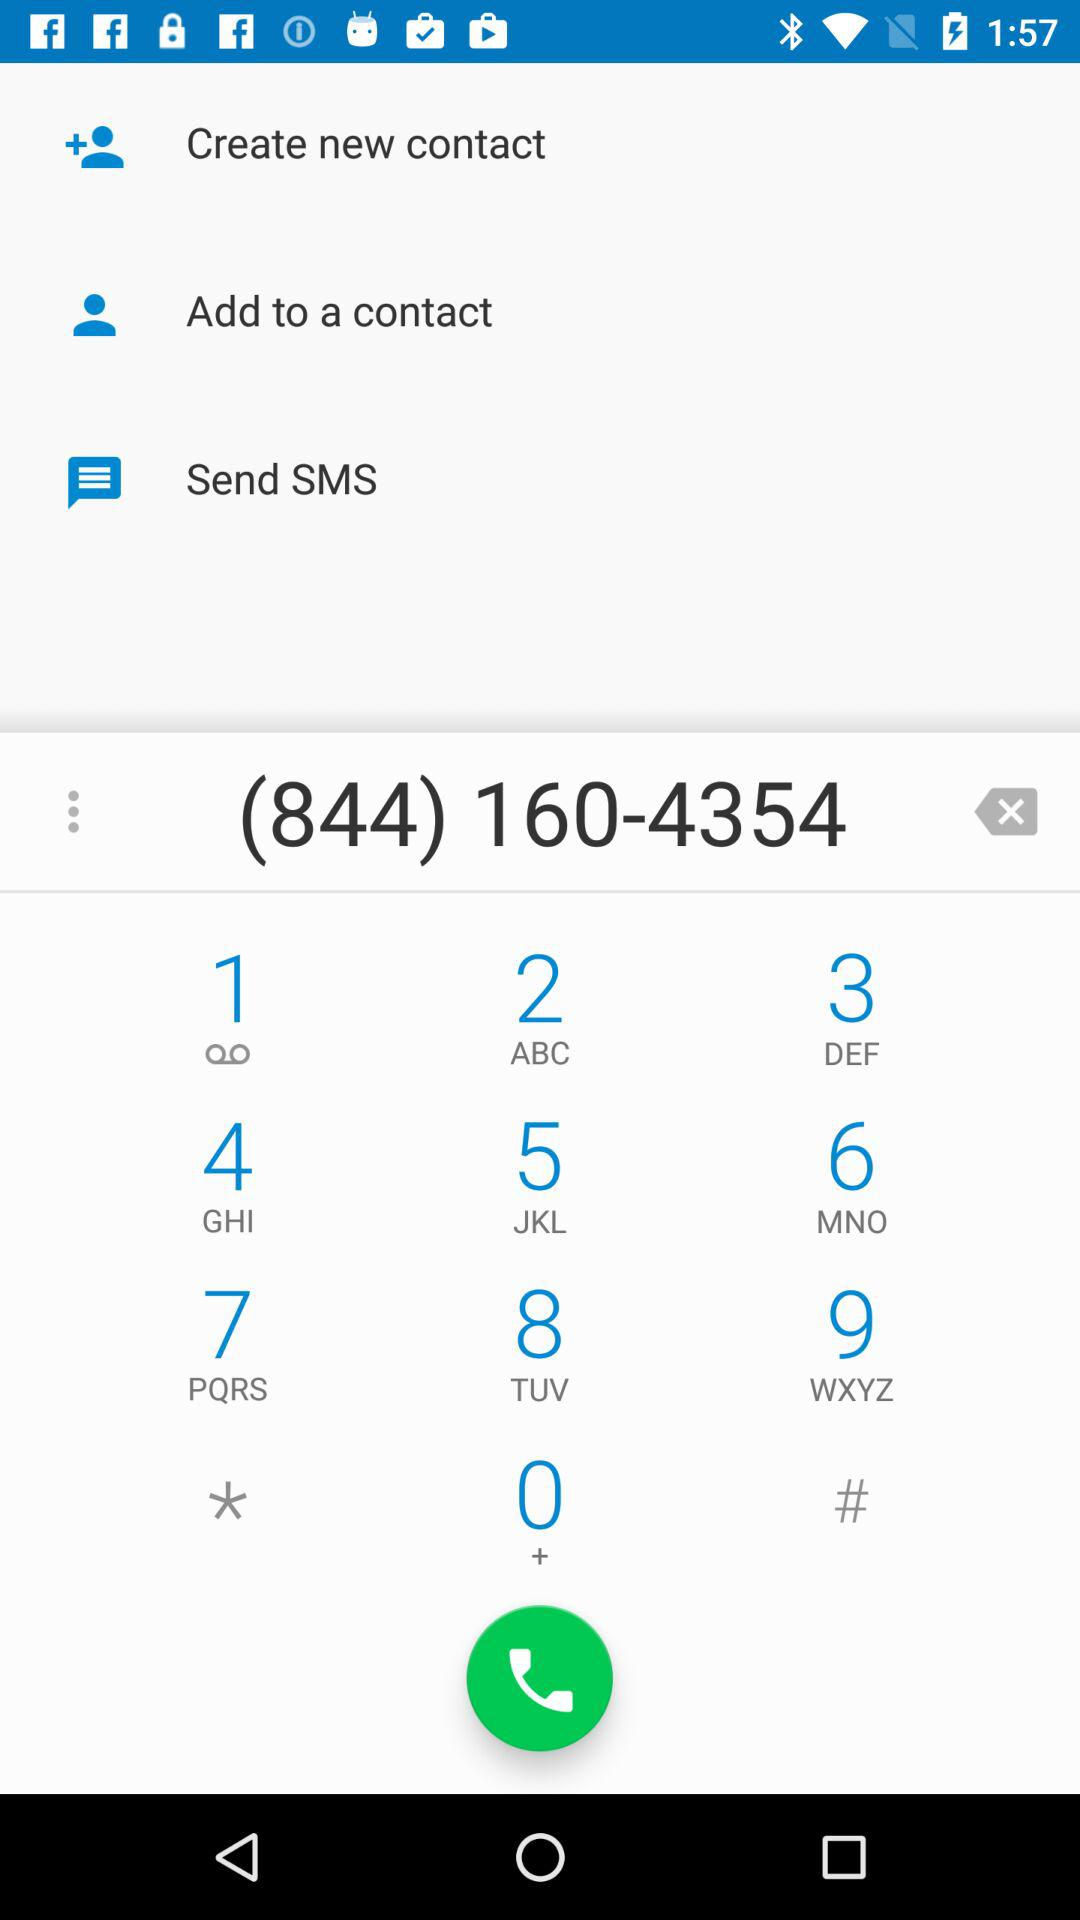What is the phone number? The phone number is (844) 160-4354. 